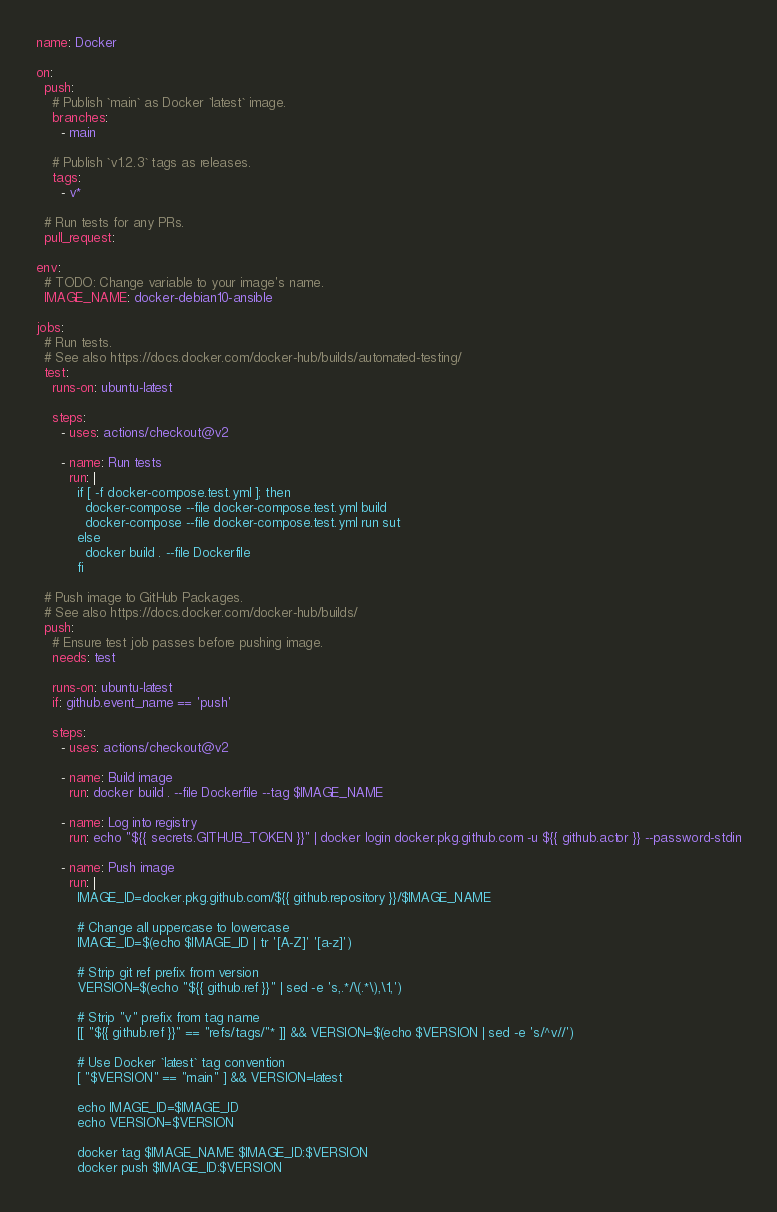<code> <loc_0><loc_0><loc_500><loc_500><_YAML_>name: Docker

on:
  push:
    # Publish `main` as Docker `latest` image.
    branches:
      - main

    # Publish `v1.2.3` tags as releases.
    tags:
      - v*

  # Run tests for any PRs.
  pull_request:

env:
  # TODO: Change variable to your image's name.
  IMAGE_NAME: docker-debian10-ansible

jobs:
  # Run tests.
  # See also https://docs.docker.com/docker-hub/builds/automated-testing/
  test:
    runs-on: ubuntu-latest

    steps:
      - uses: actions/checkout@v2

      - name: Run tests
        run: |
          if [ -f docker-compose.test.yml ]; then
            docker-compose --file docker-compose.test.yml build
            docker-compose --file docker-compose.test.yml run sut
          else
            docker build . --file Dockerfile
          fi

  # Push image to GitHub Packages.
  # See also https://docs.docker.com/docker-hub/builds/
  push:
    # Ensure test job passes before pushing image.
    needs: test

    runs-on: ubuntu-latest
    if: github.event_name == 'push'

    steps:
      - uses: actions/checkout@v2

      - name: Build image
        run: docker build . --file Dockerfile --tag $IMAGE_NAME

      - name: Log into registry
        run: echo "${{ secrets.GITHUB_TOKEN }}" | docker login docker.pkg.github.com -u ${{ github.actor }} --password-stdin

      - name: Push image
        run: |
          IMAGE_ID=docker.pkg.github.com/${{ github.repository }}/$IMAGE_NAME

          # Change all uppercase to lowercase
          IMAGE_ID=$(echo $IMAGE_ID | tr '[A-Z]' '[a-z]')

          # Strip git ref prefix from version
          VERSION=$(echo "${{ github.ref }}" | sed -e 's,.*/\(.*\),\1,')

          # Strip "v" prefix from tag name
          [[ "${{ github.ref }}" == "refs/tags/"* ]] && VERSION=$(echo $VERSION | sed -e 's/^v//')

          # Use Docker `latest` tag convention
          [ "$VERSION" == "main" ] && VERSION=latest

          echo IMAGE_ID=$IMAGE_ID
          echo VERSION=$VERSION

          docker tag $IMAGE_NAME $IMAGE_ID:$VERSION
          docker push $IMAGE_ID:$VERSION
</code> 